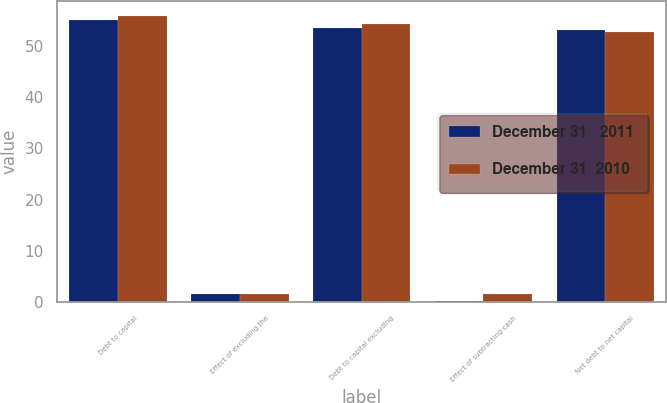Convert chart to OTSL. <chart><loc_0><loc_0><loc_500><loc_500><stacked_bar_chart><ecel><fcel>Debt to capital<fcel>Effect of excluding the<fcel>Debt to capital excluding<fcel>Effect of subtracting cash<fcel>Net debt to net capital<nl><fcel>December 31   2011<fcel>55<fcel>1.5<fcel>53.5<fcel>0.3<fcel>53.2<nl><fcel>December 31  2010<fcel>55.9<fcel>1.6<fcel>54.3<fcel>1.5<fcel>52.8<nl></chart> 